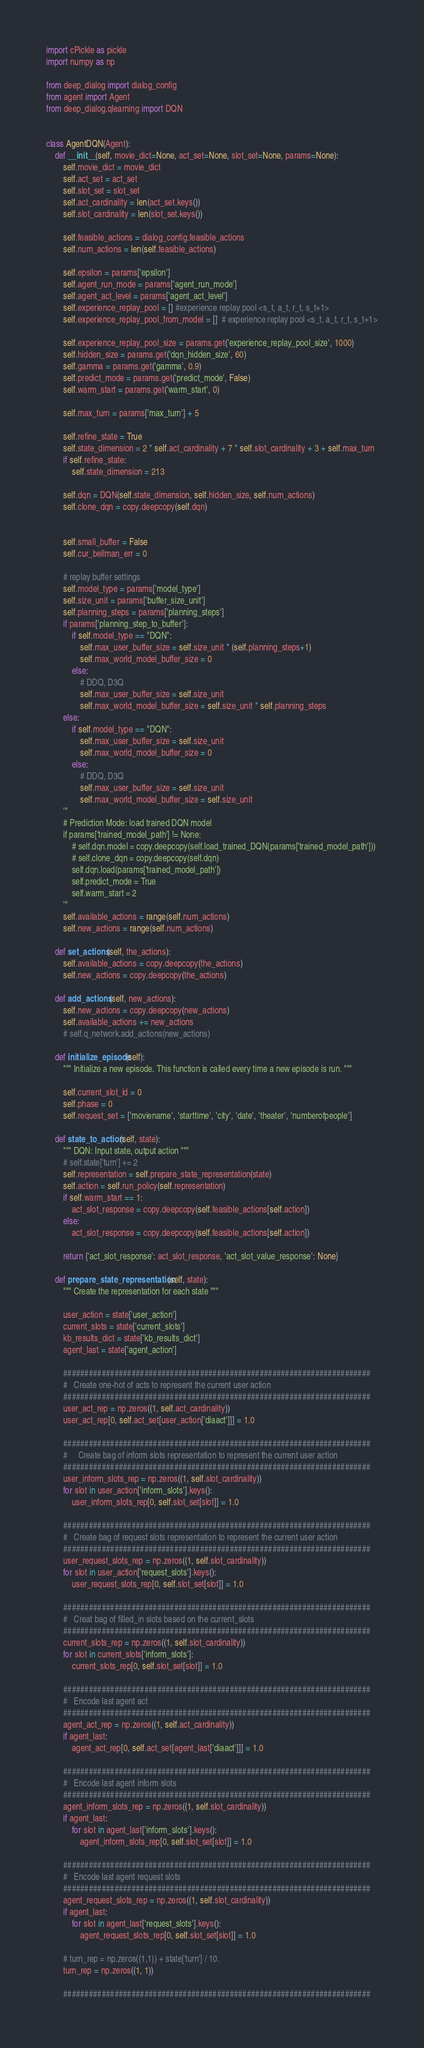Convert code to text. <code><loc_0><loc_0><loc_500><loc_500><_Python_>import cPickle as pickle
import numpy as np

from deep_dialog import dialog_config
from agent import Agent
from deep_dialog.qlearning import DQN


class AgentDQN(Agent):
    def __init__(self, movie_dict=None, act_set=None, slot_set=None, params=None):
        self.movie_dict = movie_dict
        self.act_set = act_set
        self.slot_set = slot_set
        self.act_cardinality = len(act_set.keys())
        self.slot_cardinality = len(slot_set.keys())

        self.feasible_actions = dialog_config.feasible_actions
        self.num_actions = len(self.feasible_actions)

        self.epsilon = params['epsilon']
        self.agent_run_mode = params['agent_run_mode']
        self.agent_act_level = params['agent_act_level']
        self.experience_replay_pool = [] #experience replay pool <s_t, a_t, r_t, s_t+1>
        self.experience_replay_pool_from_model = []  # experience replay pool <s_t, a_t, r_t, s_t+1>

        self.experience_replay_pool_size = params.get('experience_replay_pool_size', 1000)
        self.hidden_size = params.get('dqn_hidden_size', 60)
        self.gamma = params.get('gamma', 0.9)
        self.predict_mode = params.get('predict_mode', False)
        self.warm_start = params.get('warm_start', 0)

        self.max_turn = params['max_turn'] + 5

        self.refine_state = True
        self.state_dimension = 2 * self.act_cardinality + 7 * self.slot_cardinality + 3 + self.max_turn
        if self.refine_state:
            self.state_dimension = 213

        self.dqn = DQN(self.state_dimension, self.hidden_size, self.num_actions)
        self.clone_dqn = copy.deepcopy(self.dqn)


        self.small_buffer = False
        self.cur_bellman_err = 0

        # replay buffer settings
        self.model_type = params['model_type']
        self.size_unit = params['buffer_size_unit']
        self.planning_steps = params['planning_steps']
        if params['planning_step_to_buffer']:
            if self.model_type == "DQN":
                self.max_user_buffer_size = self.size_unit * (self.planning_steps+1)
                self.max_world_model_buffer_size = 0
            else:
                # DDQ, D3Q
                self.max_user_buffer_size = self.size_unit
                self.max_world_model_buffer_size = self.size_unit * self.planning_steps
        else:
            if self.model_type == "DQN":
                self.max_user_buffer_size = self.size_unit
                self.max_world_model_buffer_size = 0
            else:
                # DDQ, D3Q
                self.max_user_buffer_size = self.size_unit
                self.max_world_model_buffer_size = self.size_unit
        '''
        # Prediction Mode: load trained DQN model
        if params['trained_model_path'] != None:
            # self.dqn.model = copy.deepcopy(self.load_trained_DQN(params['trained_model_path']))
            # self.clone_dqn = copy.deepcopy(self.dqn)
            self.dqn.load(params['trained_model_path'])
            self.predict_mode = True
            self.warm_start = 2
        '''
        self.available_actions = range(self.num_actions)
        self.new_actions = range(self.num_actions)

    def set_actions(self, the_actions):
        self.available_actions = copy.deepcopy(the_actions)
        self.new_actions = copy.deepcopy(the_actions)

    def add_actions(self, new_actions):
        self.new_actions = copy.deepcopy(new_actions)
        self.available_actions += new_actions
        # self.q_network.add_actions(new_actions)

    def initialize_episode(self):
        """ Initialize a new episode. This function is called every time a new episode is run. """

        self.current_slot_id = 0
        self.phase = 0
        self.request_set = ['moviename', 'starttime', 'city', 'date', 'theater', 'numberofpeople']

    def state_to_action(self, state):
        """ DQN: Input state, output action """
        # self.state['turn'] += 2
        self.representation = self.prepare_state_representation(state)
        self.action = self.run_policy(self.representation)
        if self.warm_start == 1:
            act_slot_response = copy.deepcopy(self.feasible_actions[self.action])
        else:
            act_slot_response = copy.deepcopy(self.feasible_actions[self.action])

        return {'act_slot_response': act_slot_response, 'act_slot_value_response': None}

    def prepare_state_representation(self, state):
        """ Create the representation for each state """

        user_action = state['user_action']
        current_slots = state['current_slots']
        kb_results_dict = state['kb_results_dict']
        agent_last = state['agent_action']

        ########################################################################
        #   Create one-hot of acts to represent the current user action
        ########################################################################
        user_act_rep = np.zeros((1, self.act_cardinality))
        user_act_rep[0, self.act_set[user_action['diaact']]] = 1.0

        ########################################################################
        #     Create bag of inform slots representation to represent the current user action
        ########################################################################
        user_inform_slots_rep = np.zeros((1, self.slot_cardinality))
        for slot in user_action['inform_slots'].keys():
            user_inform_slots_rep[0, self.slot_set[slot]] = 1.0

        ########################################################################
        #   Create bag of request slots representation to represent the current user action
        ########################################################################
        user_request_slots_rep = np.zeros((1, self.slot_cardinality))
        for slot in user_action['request_slots'].keys():
            user_request_slots_rep[0, self.slot_set[slot]] = 1.0

        ########################################################################
        #   Creat bag of filled_in slots based on the current_slots
        ########################################################################
        current_slots_rep = np.zeros((1, self.slot_cardinality))
        for slot in current_slots['inform_slots']:
            current_slots_rep[0, self.slot_set[slot]] = 1.0

        ########################################################################
        #   Encode last agent act
        ########################################################################
        agent_act_rep = np.zeros((1, self.act_cardinality))
        if agent_last:
            agent_act_rep[0, self.act_set[agent_last['diaact']]] = 1.0

        ########################################################################
        #   Encode last agent inform slots
        ########################################################################
        agent_inform_slots_rep = np.zeros((1, self.slot_cardinality))
        if agent_last:
            for slot in agent_last['inform_slots'].keys():
                agent_inform_slots_rep[0, self.slot_set[slot]] = 1.0

        ########################################################################
        #   Encode last agent request slots
        ########################################################################
        agent_request_slots_rep = np.zeros((1, self.slot_cardinality))
        if agent_last:
            for slot in agent_last['request_slots'].keys():
                agent_request_slots_rep[0, self.slot_set[slot]] = 1.0

        # turn_rep = np.zeros((1,1)) + state['turn'] / 10.
        turn_rep = np.zeros((1, 1))

        ########################################################################</code> 